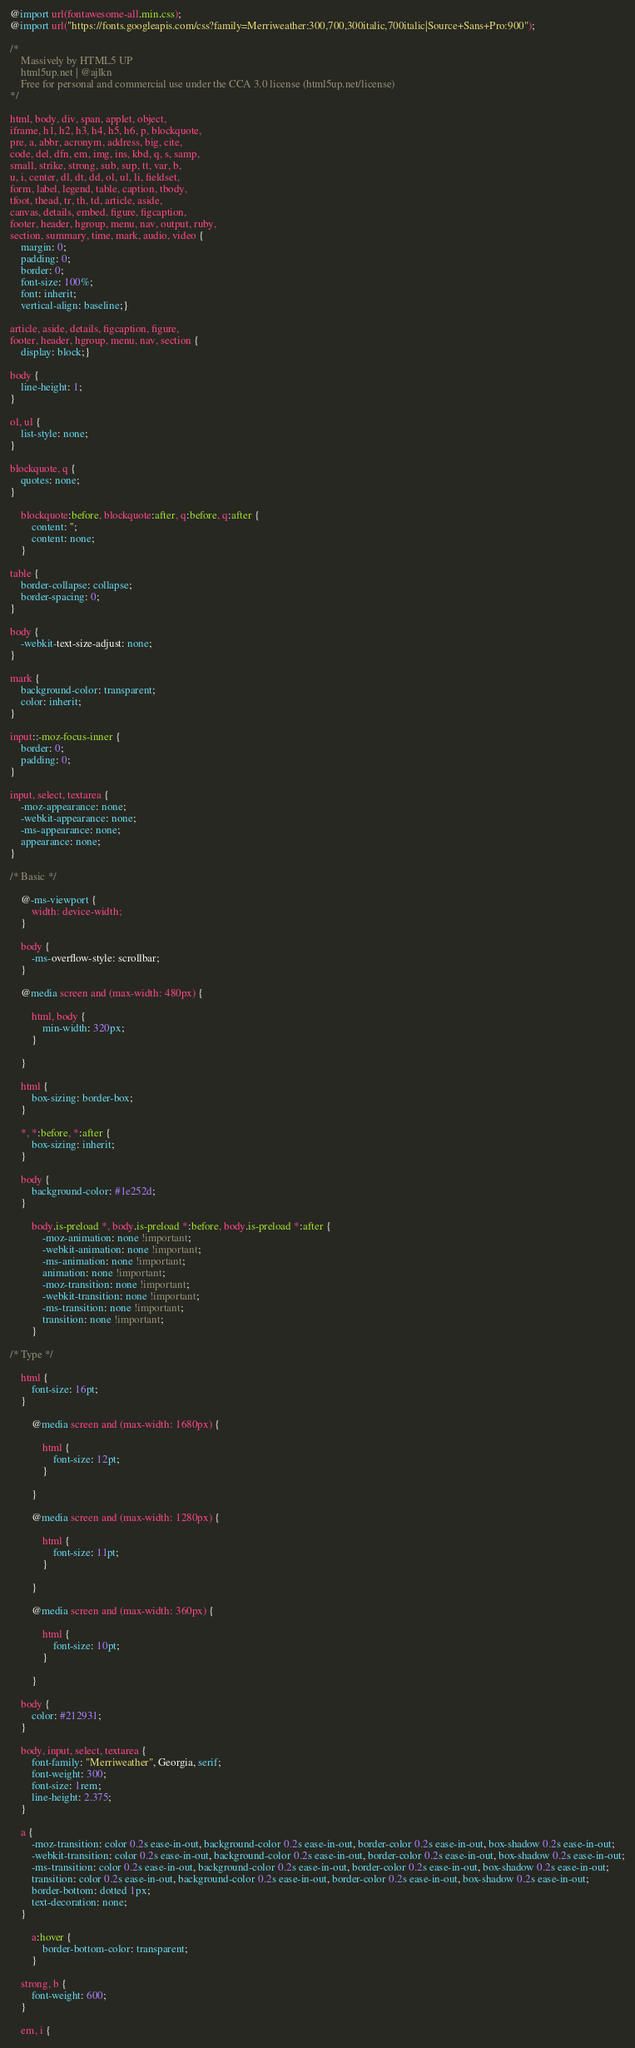<code> <loc_0><loc_0><loc_500><loc_500><_CSS_>@import url(fontawesome-all.min.css);
@import url("https://fonts.googleapis.com/css?family=Merriweather:300,700,300italic,700italic|Source+Sans+Pro:900");

/*
	Massively by HTML5 UP
	html5up.net | @ajlkn
	Free for personal and commercial use under the CCA 3.0 license (html5up.net/license)
*/

html, body, div, span, applet, object,
iframe, h1, h2, h3, h4, h5, h6, p, blockquote,
pre, a, abbr, acronym, address, big, cite,
code, del, dfn, em, img, ins, kbd, q, s, samp,
small, strike, strong, sub, sup, tt, var, b,
u, i, center, dl, dt, dd, ol, ul, li, fieldset,
form, label, legend, table, caption, tbody,
tfoot, thead, tr, th, td, article, aside,
canvas, details, embed, figure, figcaption,
footer, header, hgroup, menu, nav, output, ruby,
section, summary, time, mark, audio, video {
	margin: 0;
	padding: 0;
	border: 0;
	font-size: 100%;
	font: inherit;
	vertical-align: baseline;}

article, aside, details, figcaption, figure,
footer, header, hgroup, menu, nav, section {
	display: block;}

body {
	line-height: 1;
}

ol, ul {
	list-style: none;
}

blockquote, q {
	quotes: none;
}

	blockquote:before, blockquote:after, q:before, q:after {
		content: '';
		content: none;
	}

table {
	border-collapse: collapse;
	border-spacing: 0;
}

body {
	-webkit-text-size-adjust: none;
}

mark {
	background-color: transparent;
	color: inherit;
}

input::-moz-focus-inner {
	border: 0;
	padding: 0;
}

input, select, textarea {
	-moz-appearance: none;
	-webkit-appearance: none;
	-ms-appearance: none;
	appearance: none;
}

/* Basic */

	@-ms-viewport {
		width: device-width;
	}

	body {
		-ms-overflow-style: scrollbar;
	}

	@media screen and (max-width: 480px) {

		html, body {
			min-width: 320px;
		}

	}

	html {
		box-sizing: border-box;
	}

	*, *:before, *:after {
		box-sizing: inherit;
	}

	body {
		background-color: #1e252d;
	}

		body.is-preload *, body.is-preload *:before, body.is-preload *:after {
			-moz-animation: none !important;
			-webkit-animation: none !important;
			-ms-animation: none !important;
			animation: none !important;
			-moz-transition: none !important;
			-webkit-transition: none !important;
			-ms-transition: none !important;
			transition: none !important;
		}

/* Type */

	html {
		font-size: 16pt;
	}

		@media screen and (max-width: 1680px) {

			html {
				font-size: 12pt;
			}

		}

		@media screen and (max-width: 1280px) {

			html {
				font-size: 11pt;
			}

		}

		@media screen and (max-width: 360px) {

			html {
				font-size: 10pt;
			}

		}

	body {
		color: #212931;
	}

	body, input, select, textarea {
		font-family: "Merriweather", Georgia, serif;
		font-weight: 300;
		font-size: 1rem;
		line-height: 2.375;
	}

	a {
		-moz-transition: color 0.2s ease-in-out, background-color 0.2s ease-in-out, border-color 0.2s ease-in-out, box-shadow 0.2s ease-in-out;
		-webkit-transition: color 0.2s ease-in-out, background-color 0.2s ease-in-out, border-color 0.2s ease-in-out, box-shadow 0.2s ease-in-out;
		-ms-transition: color 0.2s ease-in-out, background-color 0.2s ease-in-out, border-color 0.2s ease-in-out, box-shadow 0.2s ease-in-out;
		transition: color 0.2s ease-in-out, background-color 0.2s ease-in-out, border-color 0.2s ease-in-out, box-shadow 0.2s ease-in-out;
		border-bottom: dotted 1px;
		text-decoration: none;
	}

		a:hover {
			border-bottom-color: transparent;
		}

	strong, b {
		font-weight: 600;
	}

	em, i {</code> 